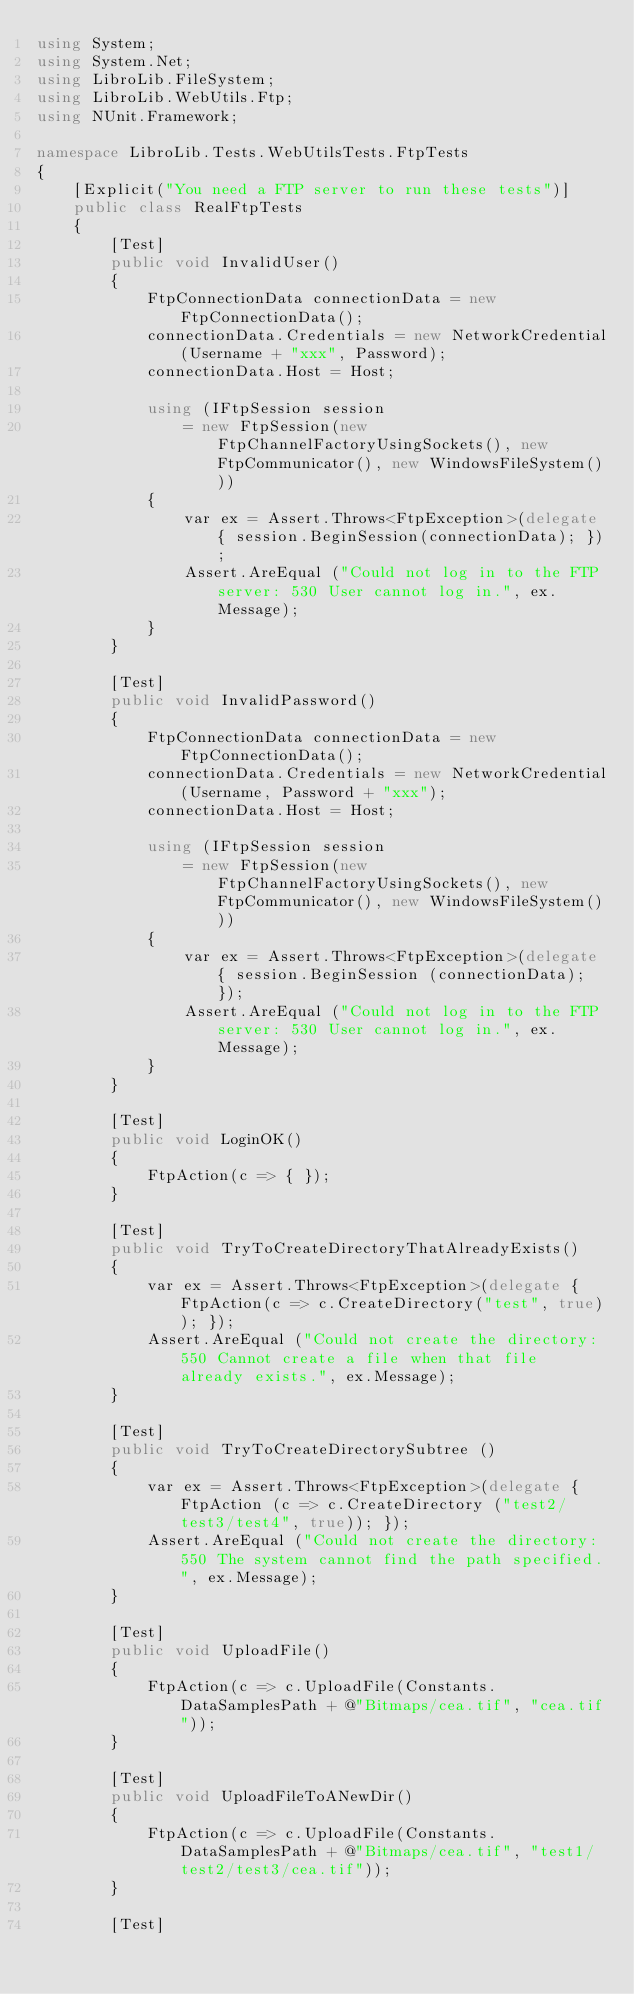<code> <loc_0><loc_0><loc_500><loc_500><_C#_>using System;
using System.Net;
using LibroLib.FileSystem;
using LibroLib.WebUtils.Ftp;
using NUnit.Framework;

namespace LibroLib.Tests.WebUtilsTests.FtpTests
{
    [Explicit("You need a FTP server to run these tests")]
    public class RealFtpTests
    {
        [Test]
        public void InvalidUser()
        {
            FtpConnectionData connectionData = new FtpConnectionData();
            connectionData.Credentials = new NetworkCredential(Username + "xxx", Password);
            connectionData.Host = Host;

            using (IFtpSession session 
                = new FtpSession(new FtpChannelFactoryUsingSockets(), new FtpCommunicator(), new WindowsFileSystem()))
            {
                var ex = Assert.Throws<FtpException>(delegate { session.BeginSession(connectionData); });
                Assert.AreEqual ("Could not log in to the FTP server: 530 User cannot log in.", ex.Message);
            }
        }

        [Test]
        public void InvalidPassword()
        {
            FtpConnectionData connectionData = new FtpConnectionData();
            connectionData.Credentials = new NetworkCredential(Username, Password + "xxx");
            connectionData.Host = Host;

            using (IFtpSession session 
                = new FtpSession(new FtpChannelFactoryUsingSockets(), new FtpCommunicator(), new WindowsFileSystem()))
            {
                var ex = Assert.Throws<FtpException>(delegate { session.BeginSession (connectionData); });
                Assert.AreEqual ("Could not log in to the FTP server: 530 User cannot log in.", ex.Message);
            }
        }

        [Test]
        public void LoginOK()
        {
            FtpAction(c => { });
        }

        [Test]
        public void TryToCreateDirectoryThatAlreadyExists()
        {
            var ex = Assert.Throws<FtpException>(delegate { FtpAction(c => c.CreateDirectory("test", true)); });
            Assert.AreEqual ("Could not create the directory: 550 Cannot create a file when that file already exists.", ex.Message);
        }

        [Test]
        public void TryToCreateDirectorySubtree ()
        {
            var ex = Assert.Throws<FtpException>(delegate { FtpAction (c => c.CreateDirectory ("test2/test3/test4", true)); });
            Assert.AreEqual ("Could not create the directory: 550 The system cannot find the path specified.", ex.Message);
        }

        [Test]
        public void UploadFile()
        {
            FtpAction(c => c.UploadFile(Constants.DataSamplesPath + @"Bitmaps/cea.tif", "cea.tif"));
        }

        [Test]
        public void UploadFileToANewDir()
        {
            FtpAction(c => c.UploadFile(Constants.DataSamplesPath + @"Bitmaps/cea.tif", "test1/test2/test3/cea.tif"));
        }

        [Test]</code> 